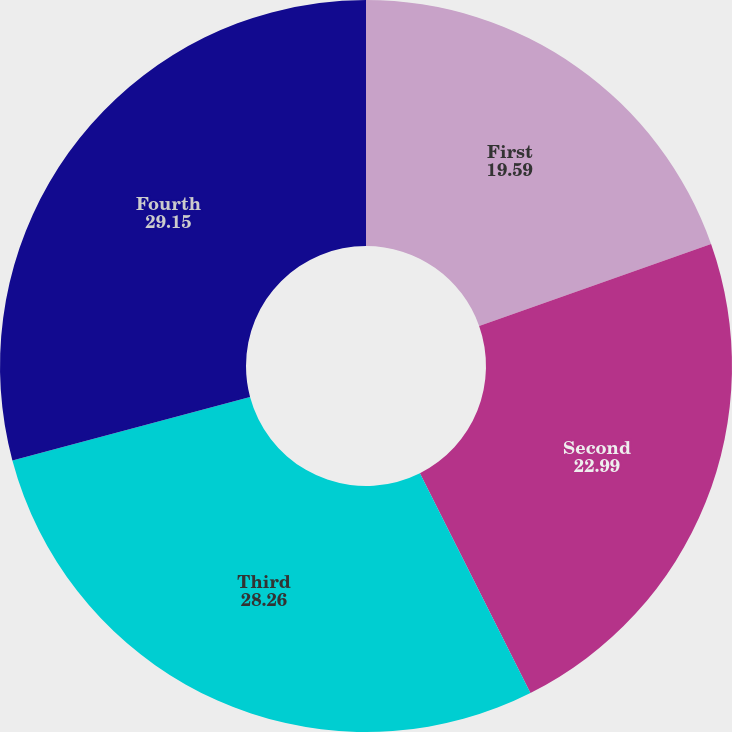<chart> <loc_0><loc_0><loc_500><loc_500><pie_chart><fcel>First<fcel>Second<fcel>Third<fcel>Fourth<nl><fcel>19.59%<fcel>22.99%<fcel>28.26%<fcel>29.15%<nl></chart> 